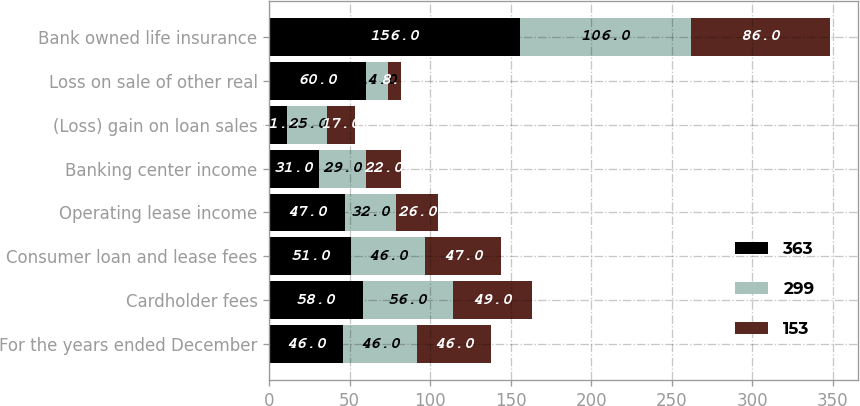Convert chart. <chart><loc_0><loc_0><loc_500><loc_500><stacked_bar_chart><ecel><fcel>For the years ended December<fcel>Cardholder fees<fcel>Consumer loan and lease fees<fcel>Operating lease income<fcel>Banking center income<fcel>(Loss) gain on loan sales<fcel>Loss on sale of other real<fcel>Bank owned life insurance<nl><fcel>363<fcel>46<fcel>58<fcel>51<fcel>47<fcel>31<fcel>11<fcel>60<fcel>156<nl><fcel>299<fcel>46<fcel>56<fcel>46<fcel>32<fcel>29<fcel>25<fcel>14<fcel>106<nl><fcel>153<fcel>46<fcel>49<fcel>47<fcel>26<fcel>22<fcel>17<fcel>8<fcel>86<nl></chart> 